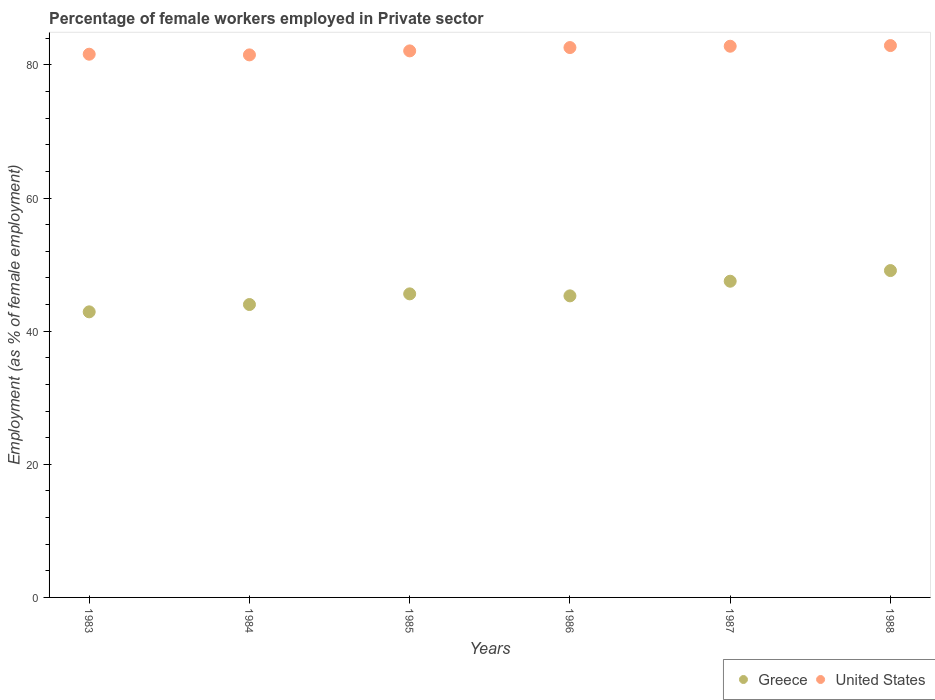What is the percentage of females employed in Private sector in Greece in 1986?
Keep it short and to the point. 45.3. Across all years, what is the maximum percentage of females employed in Private sector in Greece?
Provide a succinct answer. 49.1. Across all years, what is the minimum percentage of females employed in Private sector in Greece?
Offer a terse response. 42.9. What is the total percentage of females employed in Private sector in United States in the graph?
Give a very brief answer. 493.5. What is the difference between the percentage of females employed in Private sector in Greece in 1983 and that in 1988?
Ensure brevity in your answer.  -6.2. What is the difference between the percentage of females employed in Private sector in United States in 1988 and the percentage of females employed in Private sector in Greece in 1983?
Ensure brevity in your answer.  40. What is the average percentage of females employed in Private sector in Greece per year?
Ensure brevity in your answer.  45.73. In the year 1988, what is the difference between the percentage of females employed in Private sector in Greece and percentage of females employed in Private sector in United States?
Provide a succinct answer. -33.8. In how many years, is the percentage of females employed in Private sector in Greece greater than 4 %?
Offer a very short reply. 6. What is the ratio of the percentage of females employed in Private sector in United States in 1985 to that in 1987?
Offer a very short reply. 0.99. Is the difference between the percentage of females employed in Private sector in Greece in 1984 and 1988 greater than the difference between the percentage of females employed in Private sector in United States in 1984 and 1988?
Make the answer very short. No. What is the difference between the highest and the second highest percentage of females employed in Private sector in United States?
Offer a terse response. 0.1. What is the difference between the highest and the lowest percentage of females employed in Private sector in United States?
Make the answer very short. 1.4. Is the sum of the percentage of females employed in Private sector in United States in 1984 and 1987 greater than the maximum percentage of females employed in Private sector in Greece across all years?
Your answer should be compact. Yes. Is the percentage of females employed in Private sector in United States strictly less than the percentage of females employed in Private sector in Greece over the years?
Your answer should be compact. No. How many dotlines are there?
Give a very brief answer. 2. How many years are there in the graph?
Provide a short and direct response. 6. Does the graph contain grids?
Give a very brief answer. No. How are the legend labels stacked?
Your answer should be very brief. Horizontal. What is the title of the graph?
Your response must be concise. Percentage of female workers employed in Private sector. What is the label or title of the Y-axis?
Your answer should be very brief. Employment (as % of female employment). What is the Employment (as % of female employment) of Greece in 1983?
Provide a short and direct response. 42.9. What is the Employment (as % of female employment) in United States in 1983?
Ensure brevity in your answer.  81.6. What is the Employment (as % of female employment) in United States in 1984?
Offer a terse response. 81.5. What is the Employment (as % of female employment) in Greece in 1985?
Offer a terse response. 45.6. What is the Employment (as % of female employment) of United States in 1985?
Offer a terse response. 82.1. What is the Employment (as % of female employment) in Greece in 1986?
Your answer should be compact. 45.3. What is the Employment (as % of female employment) in United States in 1986?
Your answer should be compact. 82.6. What is the Employment (as % of female employment) of Greece in 1987?
Your response must be concise. 47.5. What is the Employment (as % of female employment) in United States in 1987?
Give a very brief answer. 82.8. What is the Employment (as % of female employment) of Greece in 1988?
Make the answer very short. 49.1. What is the Employment (as % of female employment) of United States in 1988?
Offer a very short reply. 82.9. Across all years, what is the maximum Employment (as % of female employment) in Greece?
Offer a terse response. 49.1. Across all years, what is the maximum Employment (as % of female employment) in United States?
Keep it short and to the point. 82.9. Across all years, what is the minimum Employment (as % of female employment) in Greece?
Your answer should be very brief. 42.9. Across all years, what is the minimum Employment (as % of female employment) of United States?
Give a very brief answer. 81.5. What is the total Employment (as % of female employment) of Greece in the graph?
Your response must be concise. 274.4. What is the total Employment (as % of female employment) in United States in the graph?
Your answer should be compact. 493.5. What is the difference between the Employment (as % of female employment) in Greece in 1983 and that in 1984?
Offer a terse response. -1.1. What is the difference between the Employment (as % of female employment) of Greece in 1983 and that in 1985?
Your response must be concise. -2.7. What is the difference between the Employment (as % of female employment) of Greece in 1983 and that in 1987?
Your answer should be very brief. -4.6. What is the difference between the Employment (as % of female employment) in Greece in 1983 and that in 1988?
Ensure brevity in your answer.  -6.2. What is the difference between the Employment (as % of female employment) of United States in 1983 and that in 1988?
Keep it short and to the point. -1.3. What is the difference between the Employment (as % of female employment) in Greece in 1984 and that in 1985?
Provide a succinct answer. -1.6. What is the difference between the Employment (as % of female employment) in United States in 1984 and that in 1985?
Provide a short and direct response. -0.6. What is the difference between the Employment (as % of female employment) in Greece in 1984 and that in 1986?
Make the answer very short. -1.3. What is the difference between the Employment (as % of female employment) of Greece in 1984 and that in 1987?
Give a very brief answer. -3.5. What is the difference between the Employment (as % of female employment) of United States in 1984 and that in 1987?
Your answer should be very brief. -1.3. What is the difference between the Employment (as % of female employment) in United States in 1984 and that in 1988?
Make the answer very short. -1.4. What is the difference between the Employment (as % of female employment) in Greece in 1985 and that in 1987?
Provide a succinct answer. -1.9. What is the difference between the Employment (as % of female employment) in United States in 1985 and that in 1987?
Give a very brief answer. -0.7. What is the difference between the Employment (as % of female employment) of Greece in 1985 and that in 1988?
Your answer should be compact. -3.5. What is the difference between the Employment (as % of female employment) of Greece in 1986 and that in 1987?
Your answer should be very brief. -2.2. What is the difference between the Employment (as % of female employment) in Greece in 1986 and that in 1988?
Offer a terse response. -3.8. What is the difference between the Employment (as % of female employment) in Greece in 1983 and the Employment (as % of female employment) in United States in 1984?
Offer a very short reply. -38.6. What is the difference between the Employment (as % of female employment) of Greece in 1983 and the Employment (as % of female employment) of United States in 1985?
Provide a succinct answer. -39.2. What is the difference between the Employment (as % of female employment) in Greece in 1983 and the Employment (as % of female employment) in United States in 1986?
Your answer should be very brief. -39.7. What is the difference between the Employment (as % of female employment) of Greece in 1983 and the Employment (as % of female employment) of United States in 1987?
Provide a short and direct response. -39.9. What is the difference between the Employment (as % of female employment) of Greece in 1984 and the Employment (as % of female employment) of United States in 1985?
Offer a very short reply. -38.1. What is the difference between the Employment (as % of female employment) of Greece in 1984 and the Employment (as % of female employment) of United States in 1986?
Your answer should be very brief. -38.6. What is the difference between the Employment (as % of female employment) of Greece in 1984 and the Employment (as % of female employment) of United States in 1987?
Your answer should be very brief. -38.8. What is the difference between the Employment (as % of female employment) in Greece in 1984 and the Employment (as % of female employment) in United States in 1988?
Provide a succinct answer. -38.9. What is the difference between the Employment (as % of female employment) in Greece in 1985 and the Employment (as % of female employment) in United States in 1986?
Ensure brevity in your answer.  -37. What is the difference between the Employment (as % of female employment) in Greece in 1985 and the Employment (as % of female employment) in United States in 1987?
Provide a succinct answer. -37.2. What is the difference between the Employment (as % of female employment) in Greece in 1985 and the Employment (as % of female employment) in United States in 1988?
Your response must be concise. -37.3. What is the difference between the Employment (as % of female employment) in Greece in 1986 and the Employment (as % of female employment) in United States in 1987?
Your answer should be very brief. -37.5. What is the difference between the Employment (as % of female employment) in Greece in 1986 and the Employment (as % of female employment) in United States in 1988?
Provide a short and direct response. -37.6. What is the difference between the Employment (as % of female employment) of Greece in 1987 and the Employment (as % of female employment) of United States in 1988?
Provide a succinct answer. -35.4. What is the average Employment (as % of female employment) of Greece per year?
Your answer should be very brief. 45.73. What is the average Employment (as % of female employment) in United States per year?
Keep it short and to the point. 82.25. In the year 1983, what is the difference between the Employment (as % of female employment) in Greece and Employment (as % of female employment) in United States?
Provide a succinct answer. -38.7. In the year 1984, what is the difference between the Employment (as % of female employment) in Greece and Employment (as % of female employment) in United States?
Give a very brief answer. -37.5. In the year 1985, what is the difference between the Employment (as % of female employment) of Greece and Employment (as % of female employment) of United States?
Offer a terse response. -36.5. In the year 1986, what is the difference between the Employment (as % of female employment) in Greece and Employment (as % of female employment) in United States?
Offer a very short reply. -37.3. In the year 1987, what is the difference between the Employment (as % of female employment) in Greece and Employment (as % of female employment) in United States?
Ensure brevity in your answer.  -35.3. In the year 1988, what is the difference between the Employment (as % of female employment) of Greece and Employment (as % of female employment) of United States?
Offer a very short reply. -33.8. What is the ratio of the Employment (as % of female employment) in Greece in 1983 to that in 1985?
Give a very brief answer. 0.94. What is the ratio of the Employment (as % of female employment) of United States in 1983 to that in 1985?
Make the answer very short. 0.99. What is the ratio of the Employment (as % of female employment) of Greece in 1983 to that in 1986?
Offer a terse response. 0.95. What is the ratio of the Employment (as % of female employment) of United States in 1983 to that in 1986?
Give a very brief answer. 0.99. What is the ratio of the Employment (as % of female employment) of Greece in 1983 to that in 1987?
Ensure brevity in your answer.  0.9. What is the ratio of the Employment (as % of female employment) of United States in 1983 to that in 1987?
Offer a terse response. 0.99. What is the ratio of the Employment (as % of female employment) of Greece in 1983 to that in 1988?
Offer a very short reply. 0.87. What is the ratio of the Employment (as % of female employment) of United States in 1983 to that in 1988?
Make the answer very short. 0.98. What is the ratio of the Employment (as % of female employment) of Greece in 1984 to that in 1985?
Offer a terse response. 0.96. What is the ratio of the Employment (as % of female employment) of United States in 1984 to that in 1985?
Give a very brief answer. 0.99. What is the ratio of the Employment (as % of female employment) in Greece in 1984 to that in 1986?
Provide a short and direct response. 0.97. What is the ratio of the Employment (as % of female employment) in United States in 1984 to that in 1986?
Provide a short and direct response. 0.99. What is the ratio of the Employment (as % of female employment) of Greece in 1984 to that in 1987?
Keep it short and to the point. 0.93. What is the ratio of the Employment (as % of female employment) of United States in 1984 to that in 1987?
Give a very brief answer. 0.98. What is the ratio of the Employment (as % of female employment) of Greece in 1984 to that in 1988?
Ensure brevity in your answer.  0.9. What is the ratio of the Employment (as % of female employment) of United States in 1984 to that in 1988?
Offer a terse response. 0.98. What is the ratio of the Employment (as % of female employment) in Greece in 1985 to that in 1986?
Provide a short and direct response. 1.01. What is the ratio of the Employment (as % of female employment) of Greece in 1985 to that in 1988?
Give a very brief answer. 0.93. What is the ratio of the Employment (as % of female employment) of United States in 1985 to that in 1988?
Give a very brief answer. 0.99. What is the ratio of the Employment (as % of female employment) in Greece in 1986 to that in 1987?
Offer a terse response. 0.95. What is the ratio of the Employment (as % of female employment) of Greece in 1986 to that in 1988?
Your answer should be compact. 0.92. What is the ratio of the Employment (as % of female employment) of United States in 1986 to that in 1988?
Offer a terse response. 1. What is the ratio of the Employment (as % of female employment) in Greece in 1987 to that in 1988?
Ensure brevity in your answer.  0.97. What is the difference between the highest and the second highest Employment (as % of female employment) of Greece?
Your answer should be compact. 1.6. What is the difference between the highest and the lowest Employment (as % of female employment) in United States?
Offer a terse response. 1.4. 